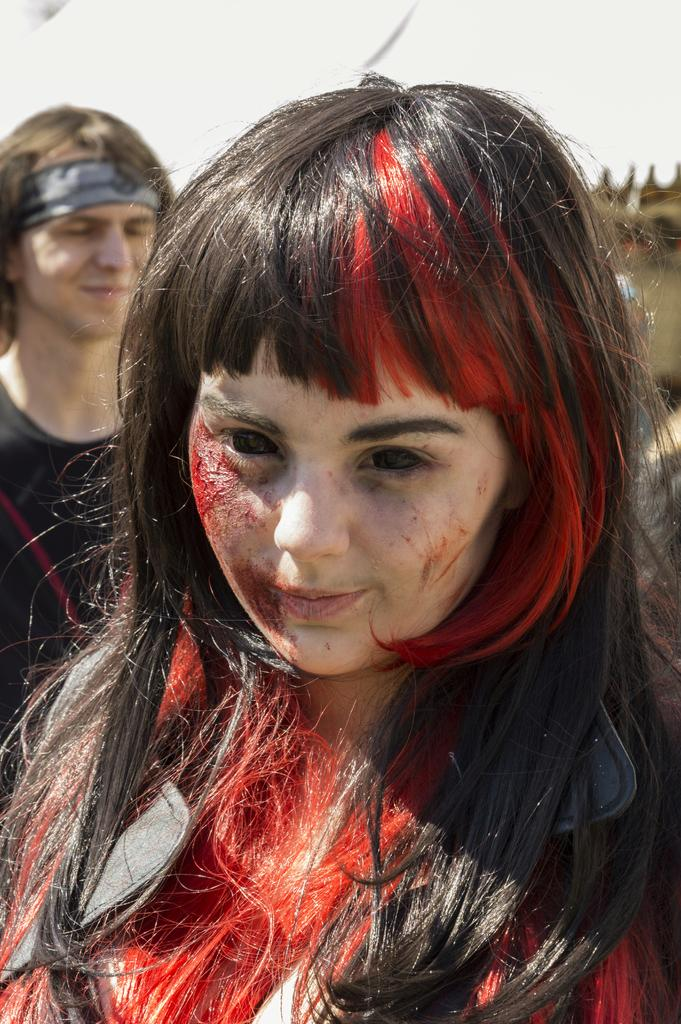Who is present in the image? There is a girl and a man in the image. Can you describe the man's attire? The man is wearing a black color dress in the image. Where is the nest located in the image? There is no nest present in the image. What information can be found on the calendar in the image? There is no calendar present in the image. 